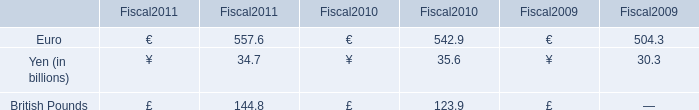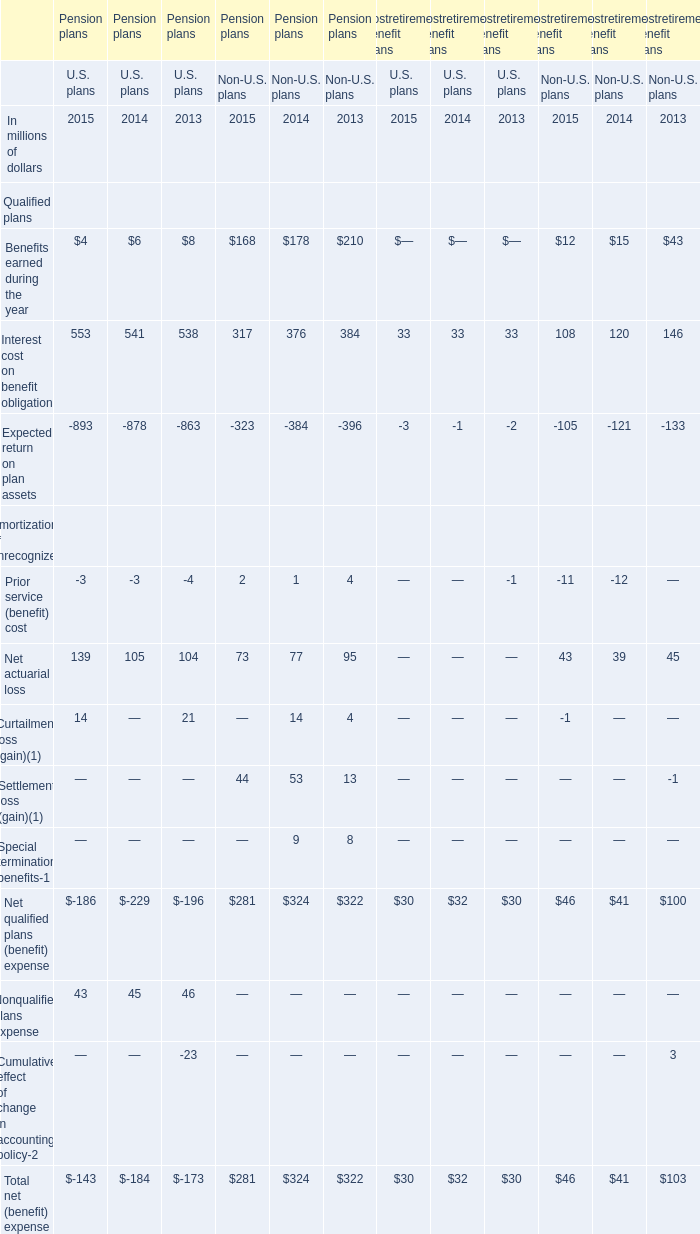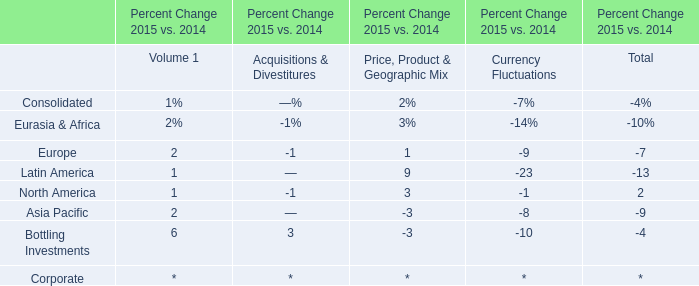In which year is Interest cost on benefit obligation for U.S. plans positive? 
Answer: 2015. 